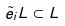<formula> <loc_0><loc_0><loc_500><loc_500>\tilde { e } _ { i } L \subset L</formula> 